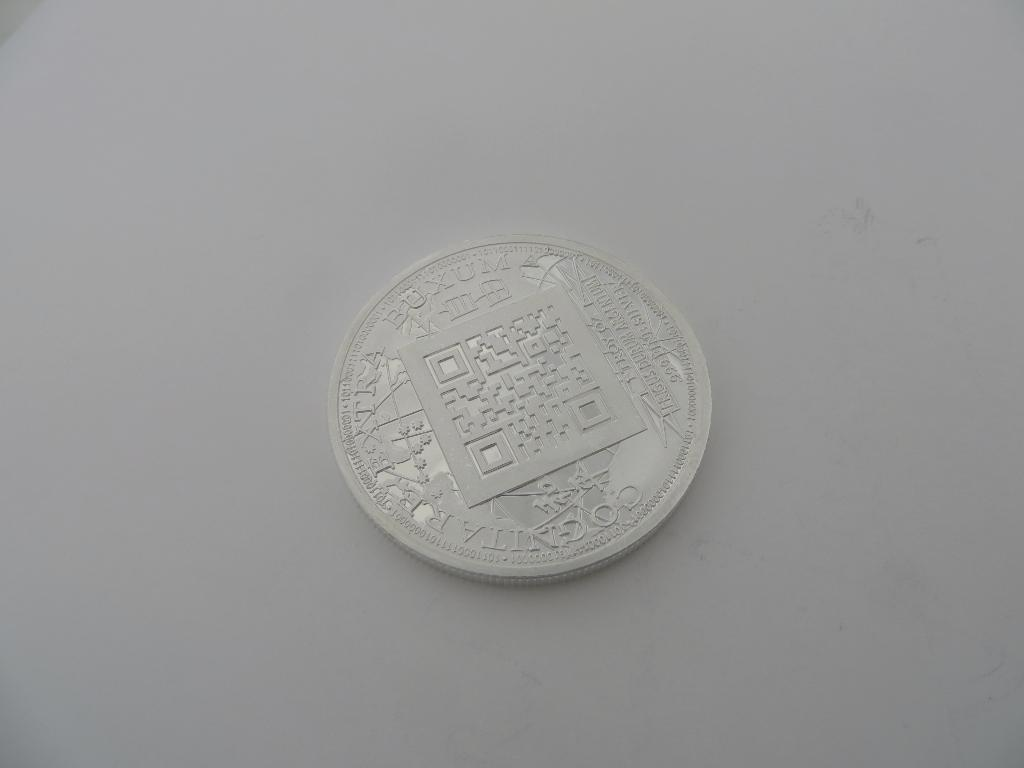<image>
Offer a succinct explanation of the picture presented. Cognitarextra Buxum is etched onto the face of this coin. 